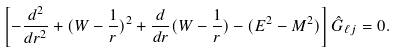<formula> <loc_0><loc_0><loc_500><loc_500>\left [ - { \frac { d ^ { 2 } } { d r ^ { 2 } } } + ( W - { \frac { 1 } { r } } ) ^ { 2 } + \frac { d } { d r } ( W - { \frac { 1 } { r } } ) - ( E ^ { 2 } - M ^ { 2 } ) \right ] \hat { G } _ { \ell j } = 0 .</formula> 